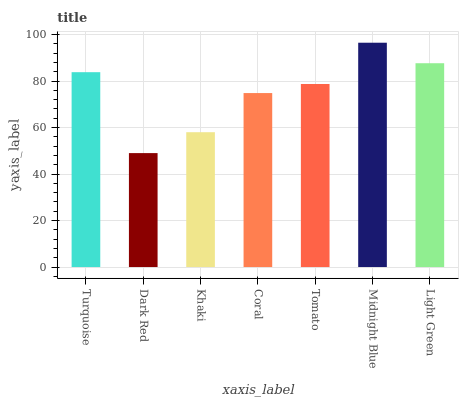Is Dark Red the minimum?
Answer yes or no. Yes. Is Midnight Blue the maximum?
Answer yes or no. Yes. Is Khaki the minimum?
Answer yes or no. No. Is Khaki the maximum?
Answer yes or no. No. Is Khaki greater than Dark Red?
Answer yes or no. Yes. Is Dark Red less than Khaki?
Answer yes or no. Yes. Is Dark Red greater than Khaki?
Answer yes or no. No. Is Khaki less than Dark Red?
Answer yes or no. No. Is Tomato the high median?
Answer yes or no. Yes. Is Tomato the low median?
Answer yes or no. Yes. Is Light Green the high median?
Answer yes or no. No. Is Khaki the low median?
Answer yes or no. No. 